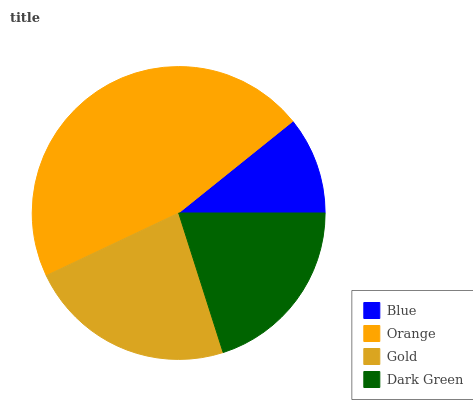Is Blue the minimum?
Answer yes or no. Yes. Is Orange the maximum?
Answer yes or no. Yes. Is Gold the minimum?
Answer yes or no. No. Is Gold the maximum?
Answer yes or no. No. Is Orange greater than Gold?
Answer yes or no. Yes. Is Gold less than Orange?
Answer yes or no. Yes. Is Gold greater than Orange?
Answer yes or no. No. Is Orange less than Gold?
Answer yes or no. No. Is Gold the high median?
Answer yes or no. Yes. Is Dark Green the low median?
Answer yes or no. Yes. Is Orange the high median?
Answer yes or no. No. Is Blue the low median?
Answer yes or no. No. 